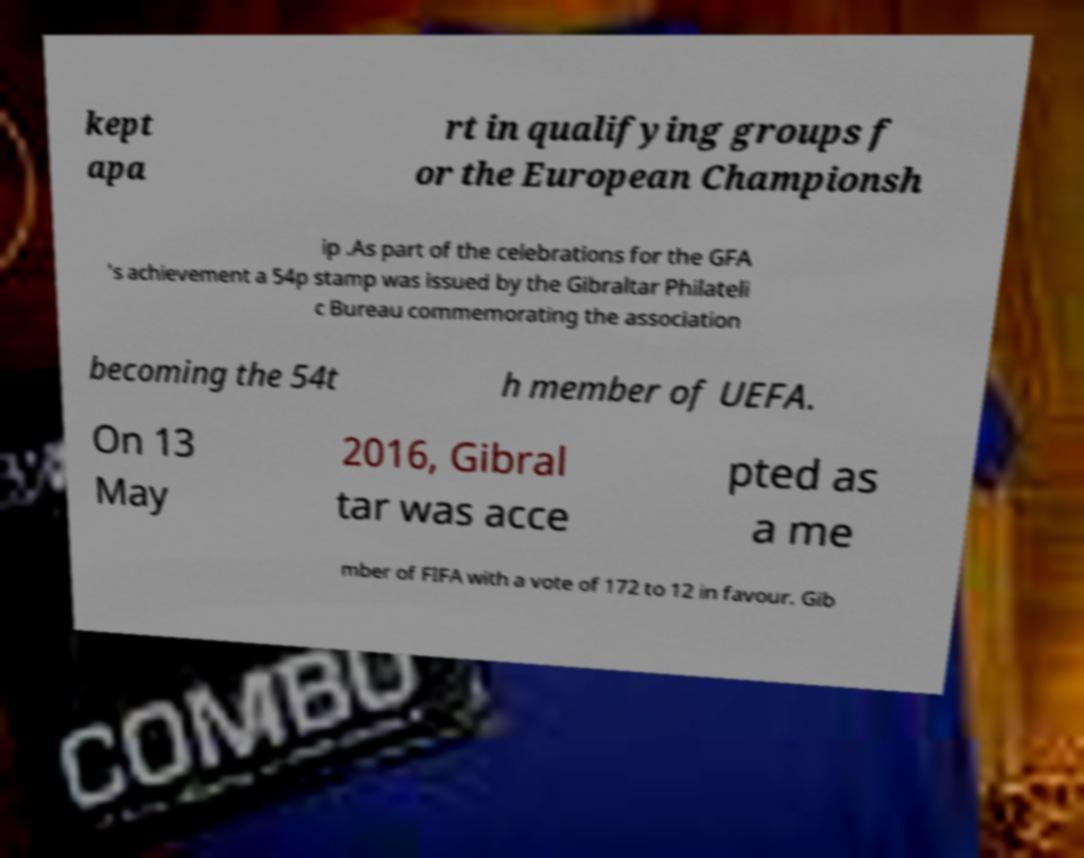What messages or text are displayed in this image? I need them in a readable, typed format. kept apa rt in qualifying groups f or the European Championsh ip .As part of the celebrations for the GFA 's achievement a 54p stamp was issued by the Gibraltar Philateli c Bureau commemorating the association becoming the 54t h member of UEFA. On 13 May 2016, Gibral tar was acce pted as a me mber of FIFA with a vote of 172 to 12 in favour. Gib 